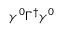<formula> <loc_0><loc_0><loc_500><loc_500>\gamma ^ { 0 } \Gamma ^ { \dagger } \gamma ^ { 0 }</formula> 